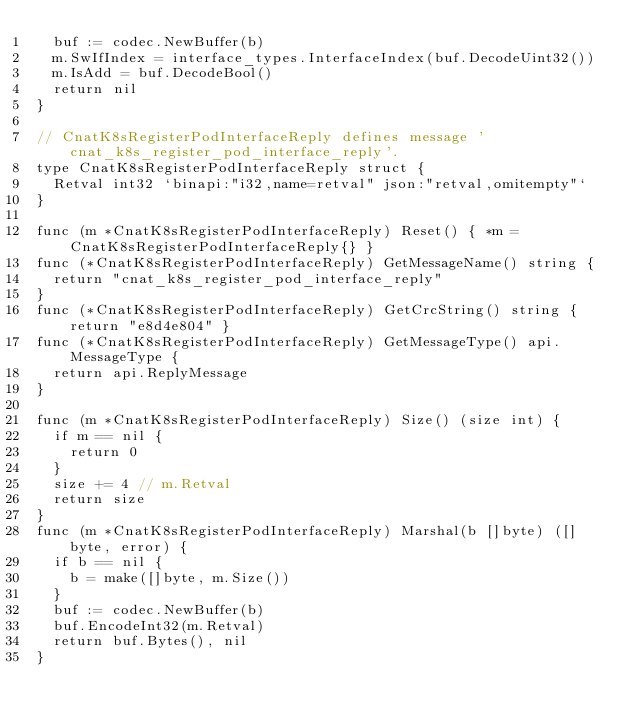<code> <loc_0><loc_0><loc_500><loc_500><_Go_>	buf := codec.NewBuffer(b)
	m.SwIfIndex = interface_types.InterfaceIndex(buf.DecodeUint32())
	m.IsAdd = buf.DecodeBool()
	return nil
}

// CnatK8sRegisterPodInterfaceReply defines message 'cnat_k8s_register_pod_interface_reply'.
type CnatK8sRegisterPodInterfaceReply struct {
	Retval int32 `binapi:"i32,name=retval" json:"retval,omitempty"`
}

func (m *CnatK8sRegisterPodInterfaceReply) Reset() { *m = CnatK8sRegisterPodInterfaceReply{} }
func (*CnatK8sRegisterPodInterfaceReply) GetMessageName() string {
	return "cnat_k8s_register_pod_interface_reply"
}
func (*CnatK8sRegisterPodInterfaceReply) GetCrcString() string { return "e8d4e804" }
func (*CnatK8sRegisterPodInterfaceReply) GetMessageType() api.MessageType {
	return api.ReplyMessage
}

func (m *CnatK8sRegisterPodInterfaceReply) Size() (size int) {
	if m == nil {
		return 0
	}
	size += 4 // m.Retval
	return size
}
func (m *CnatK8sRegisterPodInterfaceReply) Marshal(b []byte) ([]byte, error) {
	if b == nil {
		b = make([]byte, m.Size())
	}
	buf := codec.NewBuffer(b)
	buf.EncodeInt32(m.Retval)
	return buf.Bytes(), nil
}</code> 